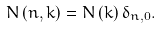Convert formula to latex. <formula><loc_0><loc_0><loc_500><loc_500>N \left ( n , k \right ) = N \left ( k \right ) \delta _ { n , 0 } .</formula> 